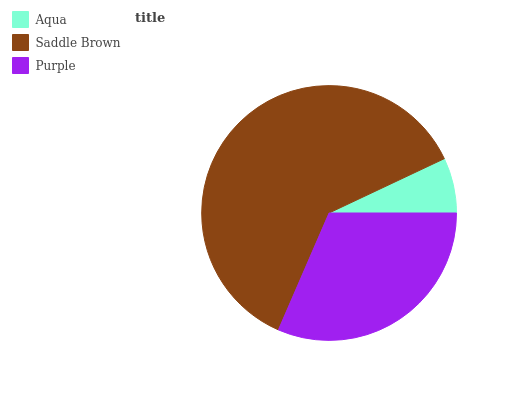Is Aqua the minimum?
Answer yes or no. Yes. Is Saddle Brown the maximum?
Answer yes or no. Yes. Is Purple the minimum?
Answer yes or no. No. Is Purple the maximum?
Answer yes or no. No. Is Saddle Brown greater than Purple?
Answer yes or no. Yes. Is Purple less than Saddle Brown?
Answer yes or no. Yes. Is Purple greater than Saddle Brown?
Answer yes or no. No. Is Saddle Brown less than Purple?
Answer yes or no. No. Is Purple the high median?
Answer yes or no. Yes. Is Purple the low median?
Answer yes or no. Yes. Is Aqua the high median?
Answer yes or no. No. Is Saddle Brown the low median?
Answer yes or no. No. 